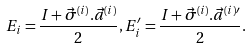<formula> <loc_0><loc_0><loc_500><loc_500>E _ { i } = \frac { I + \vec { \sigma } ^ { ( i ) } . \vec { a } ^ { ( i ) } } { 2 } , E _ { i } ^ { \prime } = \frac { I + \vec { \sigma } ^ { ( i ) } . \vec { a } ^ { ( i ) { \prime } } } { 2 } .</formula> 